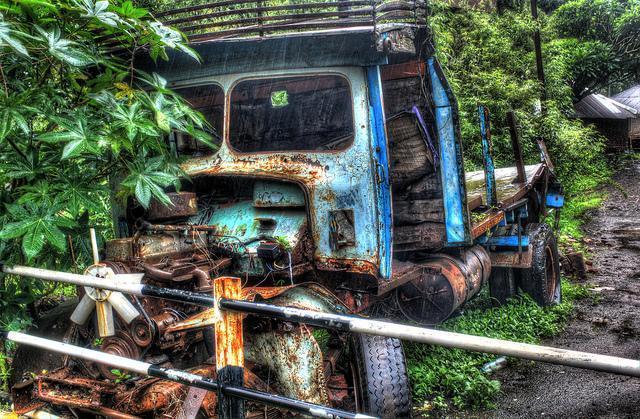How many giraffes have their heads up?
Give a very brief answer. 0. 